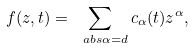<formula> <loc_0><loc_0><loc_500><loc_500>f ( z , t ) = \sum _ { \ a b s { \alpha } = d } c _ { \alpha } ( t ) z ^ { \alpha } ,</formula> 